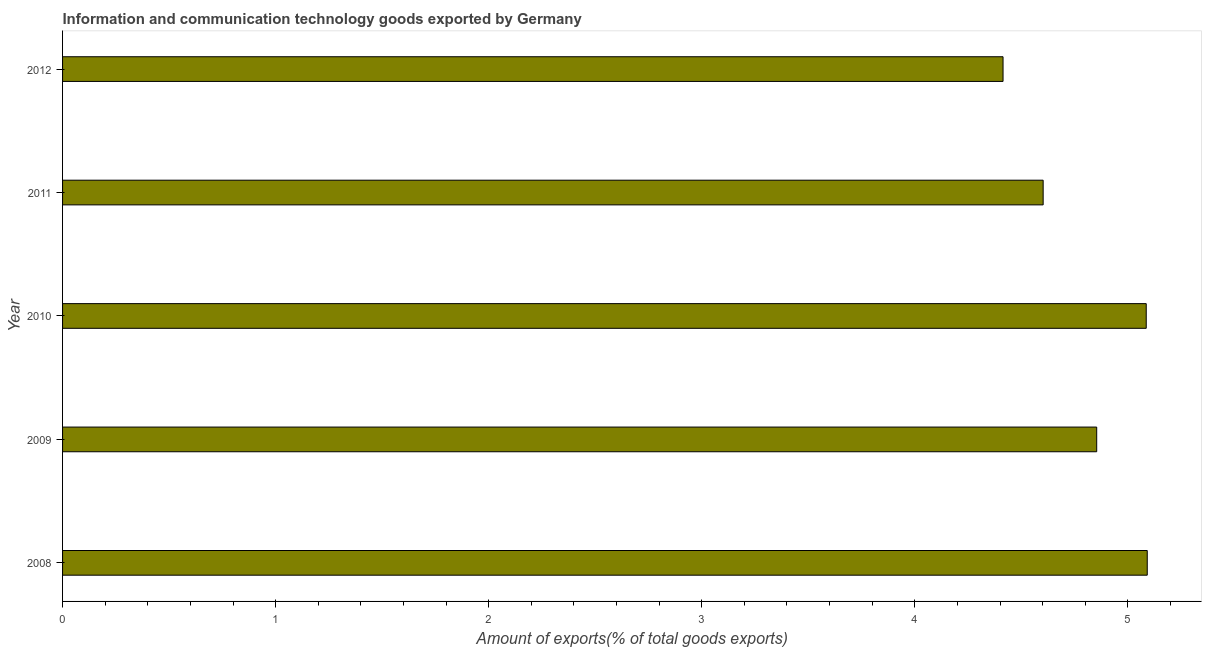Does the graph contain any zero values?
Offer a very short reply. No. What is the title of the graph?
Your response must be concise. Information and communication technology goods exported by Germany. What is the label or title of the X-axis?
Keep it short and to the point. Amount of exports(% of total goods exports). What is the amount of ict goods exports in 2009?
Offer a terse response. 4.85. Across all years, what is the maximum amount of ict goods exports?
Your answer should be very brief. 5.09. Across all years, what is the minimum amount of ict goods exports?
Make the answer very short. 4.41. In which year was the amount of ict goods exports maximum?
Provide a succinct answer. 2008. In which year was the amount of ict goods exports minimum?
Keep it short and to the point. 2012. What is the sum of the amount of ict goods exports?
Provide a succinct answer. 24.05. What is the difference between the amount of ict goods exports in 2009 and 2012?
Offer a terse response. 0.44. What is the average amount of ict goods exports per year?
Give a very brief answer. 4.81. What is the median amount of ict goods exports?
Offer a very short reply. 4.85. In how many years, is the amount of ict goods exports greater than 2.4 %?
Offer a terse response. 5. Is the amount of ict goods exports in 2008 less than that in 2011?
Provide a succinct answer. No. Is the difference between the amount of ict goods exports in 2008 and 2012 greater than the difference between any two years?
Your answer should be compact. Yes. What is the difference between the highest and the second highest amount of ict goods exports?
Give a very brief answer. 0.01. What is the difference between the highest and the lowest amount of ict goods exports?
Make the answer very short. 0.68. How many years are there in the graph?
Your response must be concise. 5. Are the values on the major ticks of X-axis written in scientific E-notation?
Make the answer very short. No. What is the Amount of exports(% of total goods exports) of 2008?
Ensure brevity in your answer.  5.09. What is the Amount of exports(% of total goods exports) of 2009?
Your response must be concise. 4.85. What is the Amount of exports(% of total goods exports) of 2010?
Your answer should be compact. 5.09. What is the Amount of exports(% of total goods exports) of 2011?
Ensure brevity in your answer.  4.6. What is the Amount of exports(% of total goods exports) of 2012?
Keep it short and to the point. 4.41. What is the difference between the Amount of exports(% of total goods exports) in 2008 and 2009?
Your answer should be compact. 0.24. What is the difference between the Amount of exports(% of total goods exports) in 2008 and 2010?
Keep it short and to the point. 0. What is the difference between the Amount of exports(% of total goods exports) in 2008 and 2011?
Offer a very short reply. 0.49. What is the difference between the Amount of exports(% of total goods exports) in 2008 and 2012?
Keep it short and to the point. 0.68. What is the difference between the Amount of exports(% of total goods exports) in 2009 and 2010?
Your answer should be very brief. -0.23. What is the difference between the Amount of exports(% of total goods exports) in 2009 and 2011?
Offer a terse response. 0.25. What is the difference between the Amount of exports(% of total goods exports) in 2009 and 2012?
Ensure brevity in your answer.  0.44. What is the difference between the Amount of exports(% of total goods exports) in 2010 and 2011?
Your answer should be compact. 0.48. What is the difference between the Amount of exports(% of total goods exports) in 2010 and 2012?
Ensure brevity in your answer.  0.67. What is the difference between the Amount of exports(% of total goods exports) in 2011 and 2012?
Provide a short and direct response. 0.19. What is the ratio of the Amount of exports(% of total goods exports) in 2008 to that in 2009?
Offer a very short reply. 1.05. What is the ratio of the Amount of exports(% of total goods exports) in 2008 to that in 2010?
Keep it short and to the point. 1. What is the ratio of the Amount of exports(% of total goods exports) in 2008 to that in 2011?
Ensure brevity in your answer.  1.11. What is the ratio of the Amount of exports(% of total goods exports) in 2008 to that in 2012?
Keep it short and to the point. 1.15. What is the ratio of the Amount of exports(% of total goods exports) in 2009 to that in 2010?
Your answer should be compact. 0.95. What is the ratio of the Amount of exports(% of total goods exports) in 2009 to that in 2011?
Provide a succinct answer. 1.05. What is the ratio of the Amount of exports(% of total goods exports) in 2009 to that in 2012?
Make the answer very short. 1.1. What is the ratio of the Amount of exports(% of total goods exports) in 2010 to that in 2011?
Provide a succinct answer. 1.1. What is the ratio of the Amount of exports(% of total goods exports) in 2010 to that in 2012?
Ensure brevity in your answer.  1.15. What is the ratio of the Amount of exports(% of total goods exports) in 2011 to that in 2012?
Provide a succinct answer. 1.04. 